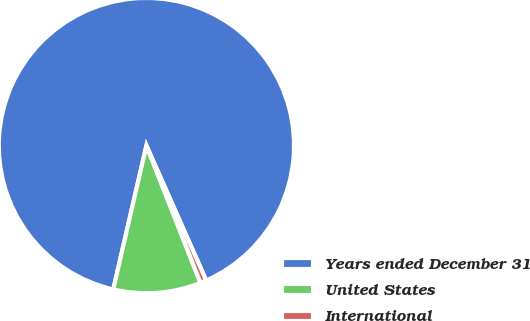<chart> <loc_0><loc_0><loc_500><loc_500><pie_chart><fcel>Years ended December 31<fcel>United States<fcel>International<nl><fcel>89.76%<fcel>9.58%<fcel>0.67%<nl></chart> 